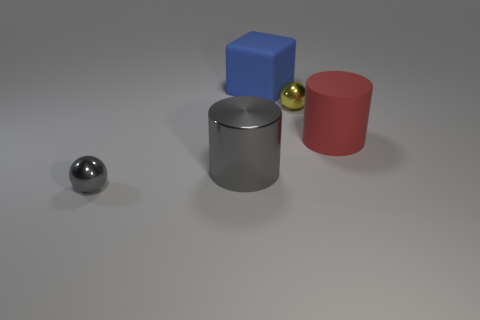Add 4 small red cubes. How many objects exist? 9 Subtract all cubes. How many objects are left? 4 Add 3 small gray metallic balls. How many small gray metallic balls are left? 4 Add 5 blue matte things. How many blue matte things exist? 6 Subtract 0 brown balls. How many objects are left? 5 Subtract all gray cylinders. Subtract all big cyan matte cubes. How many objects are left? 4 